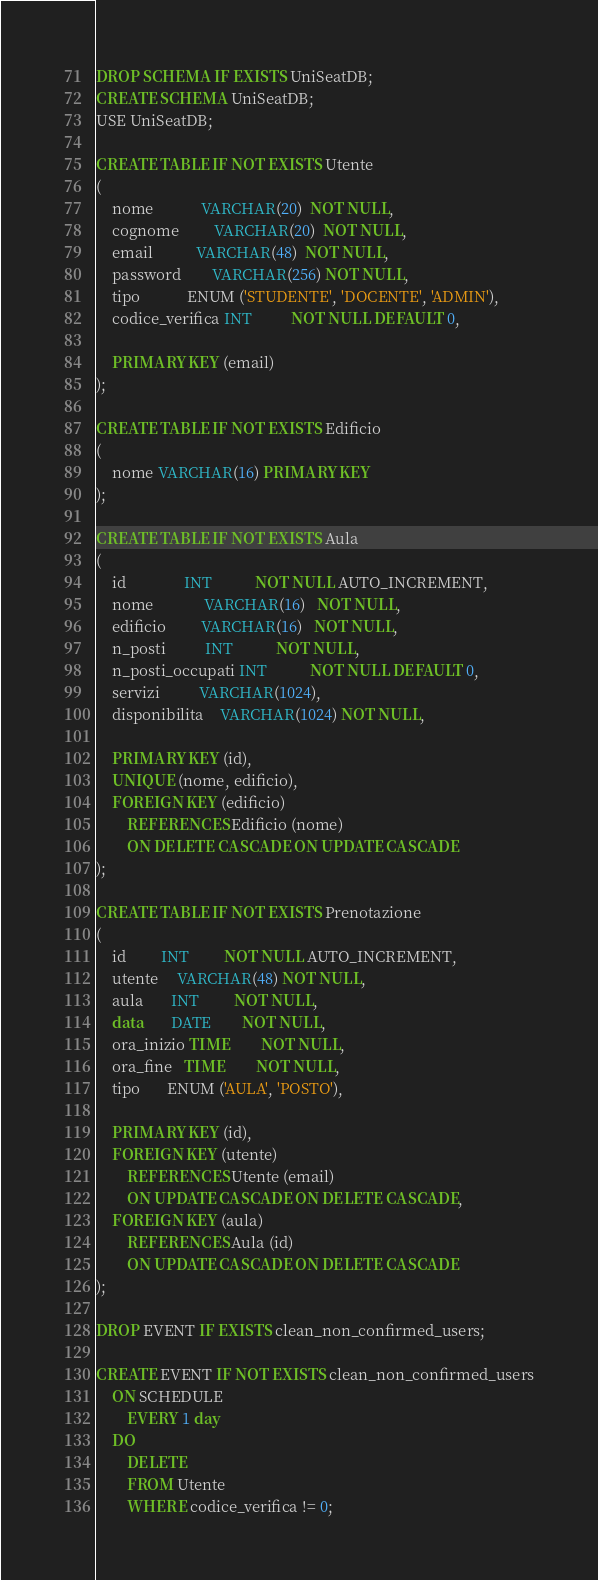Convert code to text. <code><loc_0><loc_0><loc_500><loc_500><_SQL_>DROP SCHEMA IF EXISTS UniSeatDB;
CREATE SCHEMA UniSeatDB;
USE UniSeatDB;

CREATE TABLE IF NOT EXISTS Utente
(
    nome            VARCHAR(20)  NOT NULL,
    cognome         VARCHAR(20)  NOT NULL,
    email           VARCHAR(48)  NOT NULL,
    password        VARCHAR(256) NOT NULL,
    tipo            ENUM ('STUDENTE', 'DOCENTE', 'ADMIN'),
    codice_verifica INT          NOT NULL DEFAULT 0,

    PRIMARY KEY (email)
);

CREATE TABLE IF NOT EXISTS Edificio
(
    nome VARCHAR(16) PRIMARY KEY
);

CREATE TABLE IF NOT EXISTS Aula
(
    id               INT           NOT NULL AUTO_INCREMENT,
    nome             VARCHAR(16)   NOT NULL,
    edificio         VARCHAR(16)   NOT NULL,
    n_posti          INT           NOT NULL,
    n_posti_occupati INT           NOT NULL DEFAULT 0,
    servizi          VARCHAR(1024),
    disponibilita    VARCHAR(1024) NOT NULL,

    PRIMARY KEY (id),
    UNIQUE (nome, edificio),
    FOREIGN KEY (edificio)
        REFERENCES Edificio (nome)
        ON DELETE CASCADE ON UPDATE CASCADE
);

CREATE TABLE IF NOT EXISTS Prenotazione
(
    id         INT         NOT NULL AUTO_INCREMENT,
    utente     VARCHAR(48) NOT NULL,
    aula       INT         NOT NULL,
    data       DATE        NOT NULL,
    ora_inizio TIME        NOT NULL,
    ora_fine   TIME        NOT NULL,
    tipo       ENUM ('AULA', 'POSTO'),

    PRIMARY KEY (id),
    FOREIGN KEY (utente)
        REFERENCES Utente (email)
        ON UPDATE CASCADE ON DELETE CASCADE,
    FOREIGN KEY (aula)
        REFERENCES Aula (id)
        ON UPDATE CASCADE ON DELETE CASCADE
);

DROP EVENT IF EXISTS clean_non_confirmed_users;

CREATE EVENT IF NOT EXISTS clean_non_confirmed_users
    ON SCHEDULE
        EVERY 1 day
    DO
        DELETE
        FROM Utente
        WHERE codice_verifica != 0;</code> 